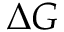Convert formula to latex. <formula><loc_0><loc_0><loc_500><loc_500>\Delta G</formula> 